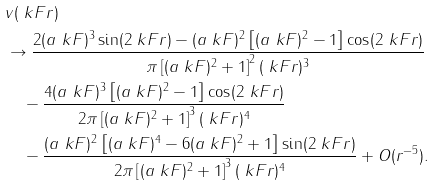Convert formula to latex. <formula><loc_0><loc_0><loc_500><loc_500>& v ( \ k F r ) \\ & \to \frac { 2 ( a \ k F ) ^ { 3 } \sin ( 2 \ k F r ) - ( a \ k F ) ^ { 2 } \left [ ( a \ k F ) ^ { 2 } - 1 \right ] \cos ( 2 \ k F r ) } { \pi \left [ ( a \ k F ) ^ { 2 } + 1 \right ] ^ { 2 } ( \ k F r ) ^ { 3 } } \\ & \quad - \frac { 4 ( a \ k F ) ^ { 3 } \left [ ( a \ k F ) ^ { 2 } - 1 \right ] \cos ( 2 \ k F r ) } { 2 \pi \left [ ( a \ k F ) ^ { 2 } + 1 \right ] ^ { 3 } ( \ k F r ) ^ { 4 } } \\ & \quad - \frac { ( a \ k F ) ^ { 2 } \left [ ( a \ k F ) ^ { 4 } - 6 ( a \ k F ) ^ { 2 } + 1 \right ] \sin ( 2 \ k F r ) } { 2 \pi \left [ ( a \ k F ) ^ { 2 } + 1 \right ] ^ { 3 } ( \ k F r ) ^ { 4 } } + O ( r ^ { - 5 } ) .</formula> 